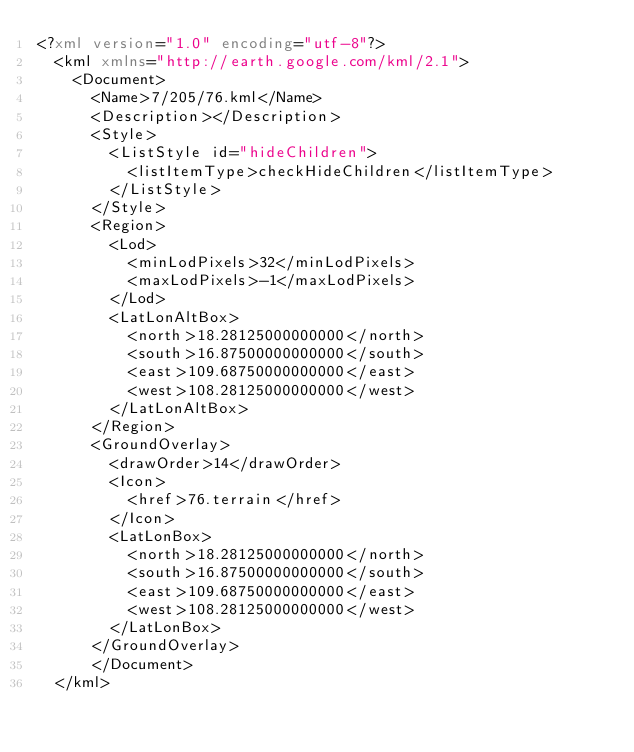Convert code to text. <code><loc_0><loc_0><loc_500><loc_500><_XML_><?xml version="1.0" encoding="utf-8"?>
	<kml xmlns="http://earth.google.com/kml/2.1">
	  <Document>
	    <Name>7/205/76.kml</Name>
	    <Description></Description>
	    <Style>
	      <ListStyle id="hideChildren">
	        <listItemType>checkHideChildren</listItemType>
	      </ListStyle>
	    </Style>
	    <Region>
	      <Lod>
	        <minLodPixels>32</minLodPixels>
	        <maxLodPixels>-1</maxLodPixels>
	      </Lod>
	      <LatLonAltBox>
	        <north>18.28125000000000</north>
	        <south>16.87500000000000</south>
	        <east>109.68750000000000</east>
	        <west>108.28125000000000</west>
	      </LatLonAltBox>
	    </Region>
	    <GroundOverlay>
	      <drawOrder>14</drawOrder>
	      <Icon>
	        <href>76.terrain</href>
	      </Icon>
	      <LatLonBox>
	        <north>18.28125000000000</north>
	        <south>16.87500000000000</south>
	        <east>109.68750000000000</east>
	        <west>108.28125000000000</west>
	      </LatLonBox>
	    </GroundOverlay>
		  </Document>
	</kml>
	</code> 